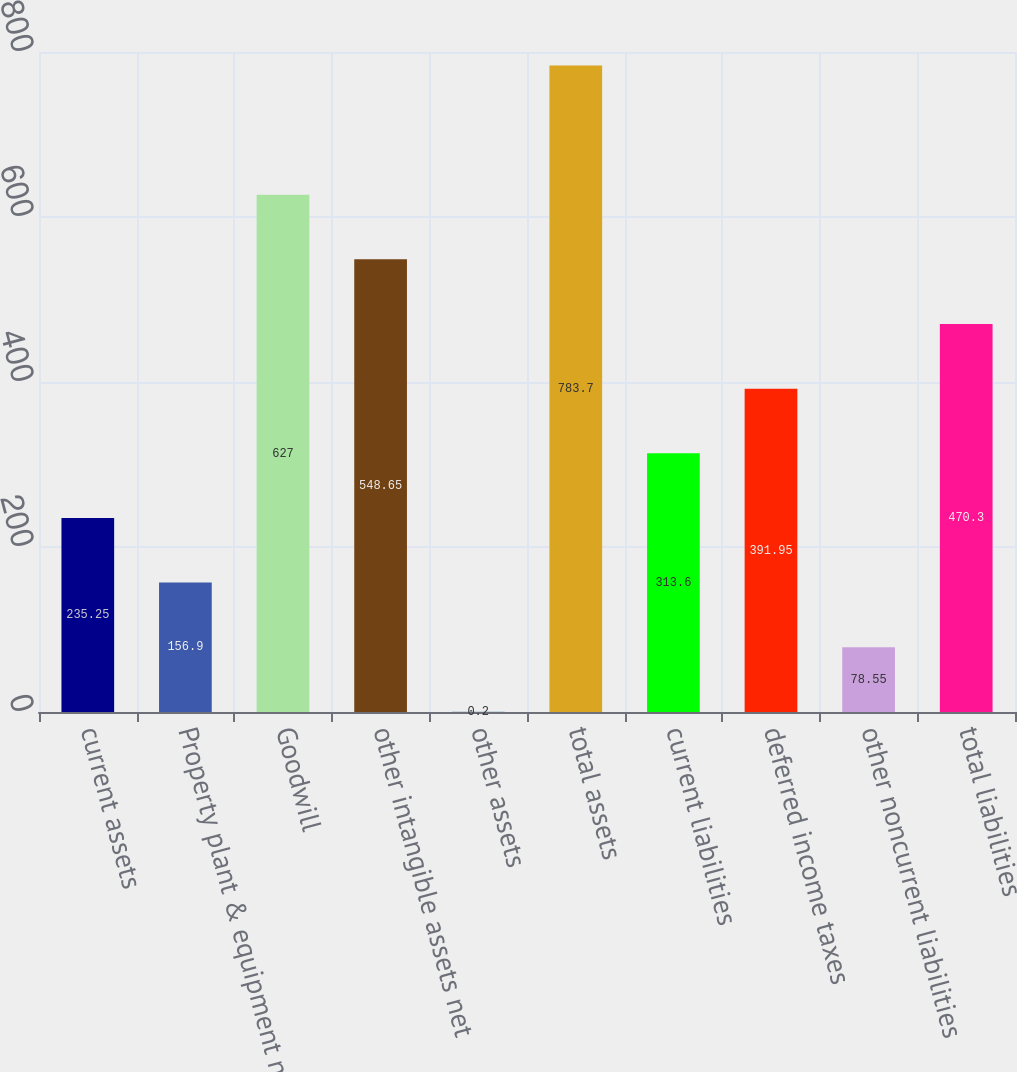Convert chart to OTSL. <chart><loc_0><loc_0><loc_500><loc_500><bar_chart><fcel>current assets<fcel>Property plant & equipment net<fcel>Goodwill<fcel>other intangible assets net<fcel>other assets<fcel>total assets<fcel>current liabilities<fcel>deferred income taxes<fcel>other noncurrent liabilities<fcel>total liabilities<nl><fcel>235.25<fcel>156.9<fcel>627<fcel>548.65<fcel>0.2<fcel>783.7<fcel>313.6<fcel>391.95<fcel>78.55<fcel>470.3<nl></chart> 